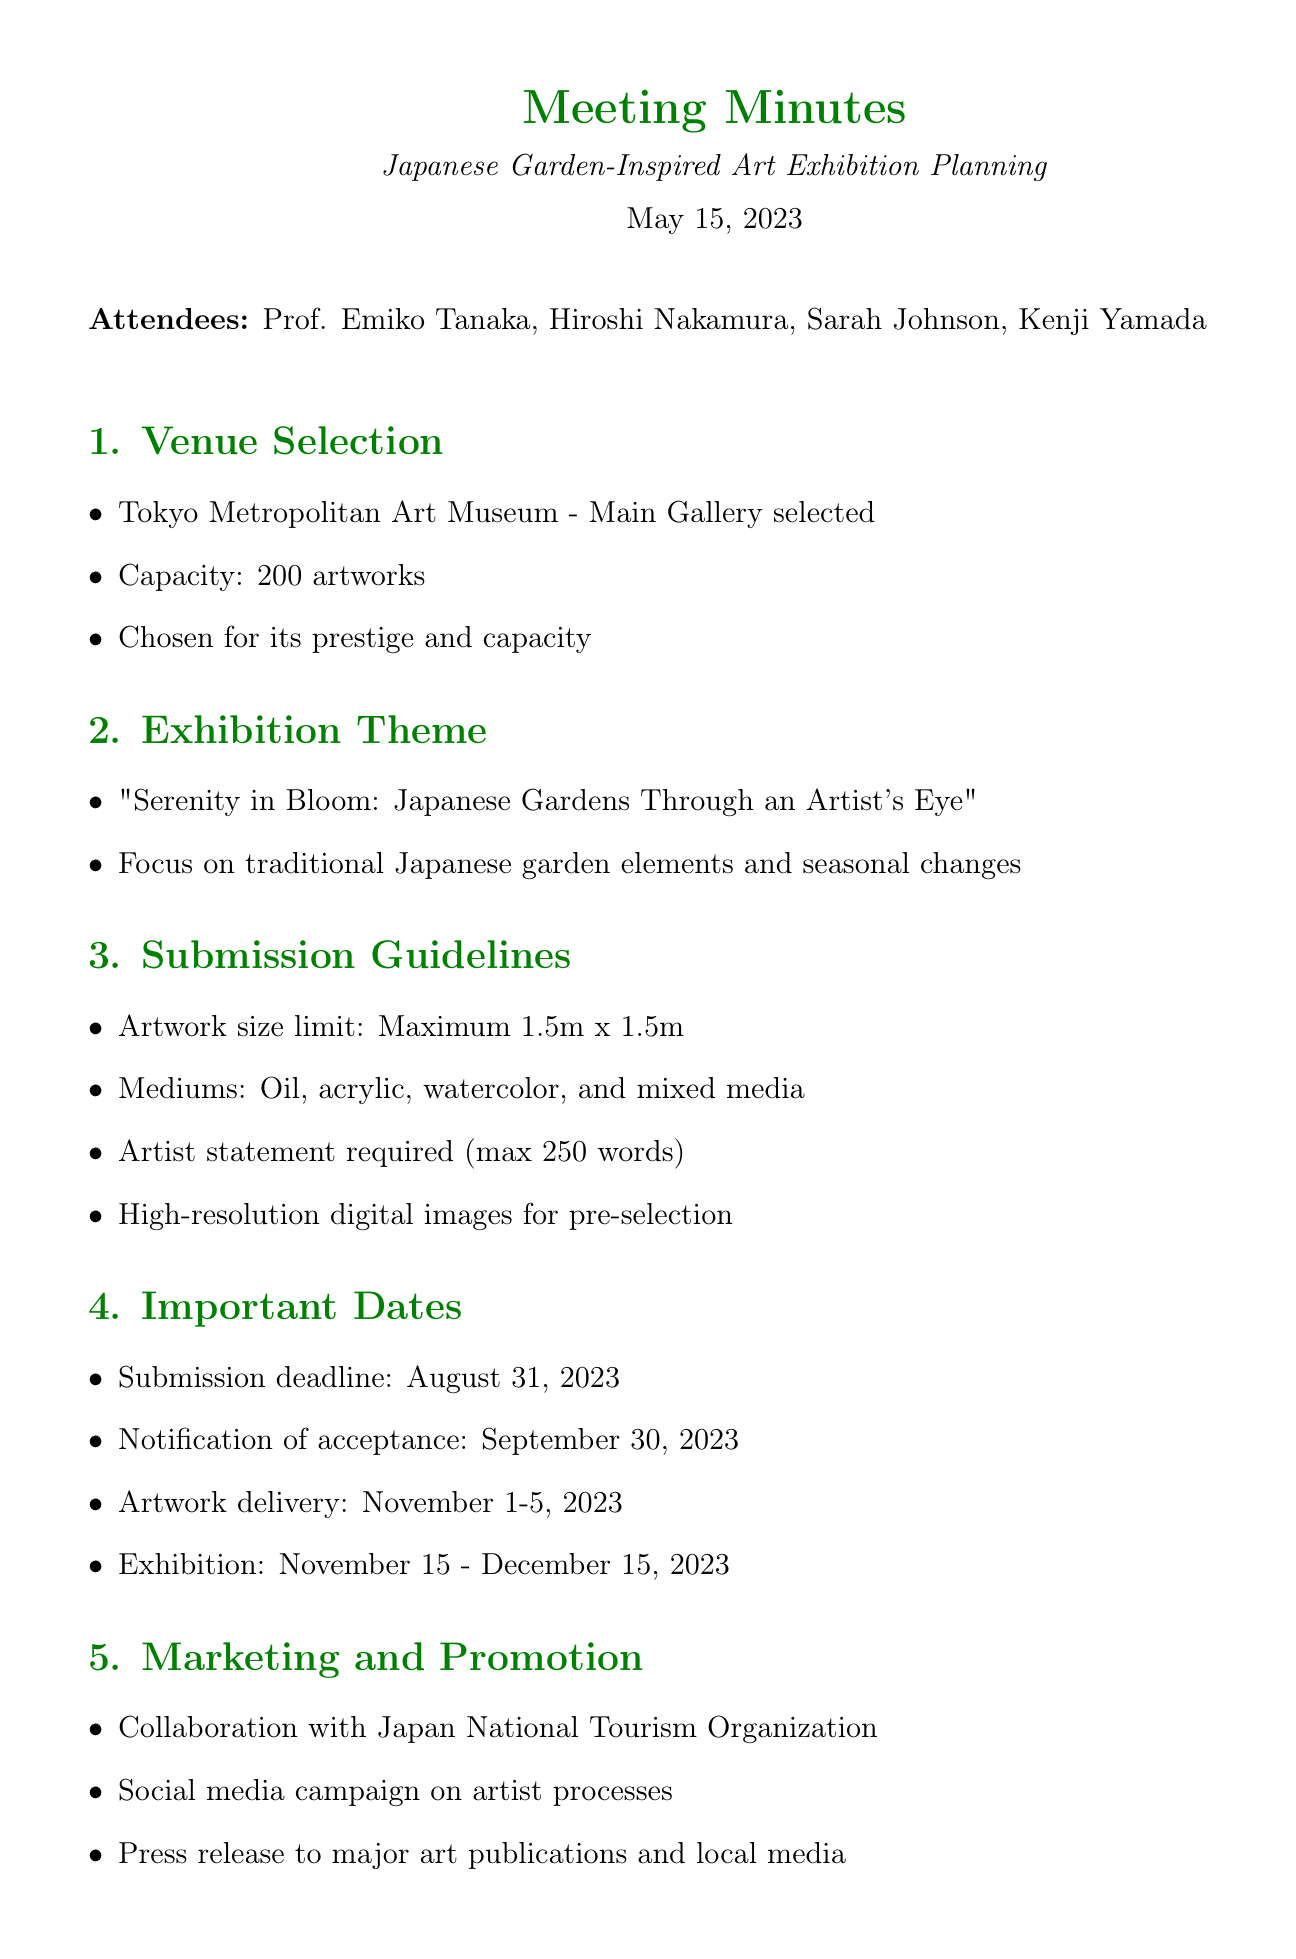What is the date of the meeting? The date of the meeting is clearly stated in the document header.
Answer: May 15, 2023 Who is the event coordinator mentioned in the meeting? The attendees list provides the names and roles of participants in the meeting, including the event coordinator.
Answer: Kenji Yamada What is the capacity of the Tokyo Metropolitan Art Museum's main gallery? The discussion points under the venue selection section specify the capacity of the chosen venue.
Answer: 200 artworks What is the maximum size limit for artworks submitted? The submission guidelines discuss the restrictions on artwork sizes.
Answer: Maximum 1.5m x 1.5m When is the submission deadline for the exhibition? Important dates listed in the document include the submission deadline for artworks.
Answer: August 31, 2023 What is the theme of the exhibition? The exhibition theme is stated under the exhibition theme discussion points.
Answer: "Serenity in Bloom: Japanese Gardens Through an Artist's Eye" How many days are allocated for artwork delivery to the venue? The important dates section details the time frame for artwork delivery.
Answer: 5 days What is required from artists along with their artwork submissions? The submission guidelines outline the necessary documents artists must provide for consideration.
Answer: Artist statement required (max 250 words) Who is responsible for confirming the venue booking? The action items specify who is assigned various tasks, including confirming the venue.
Answer: Hiroshi 